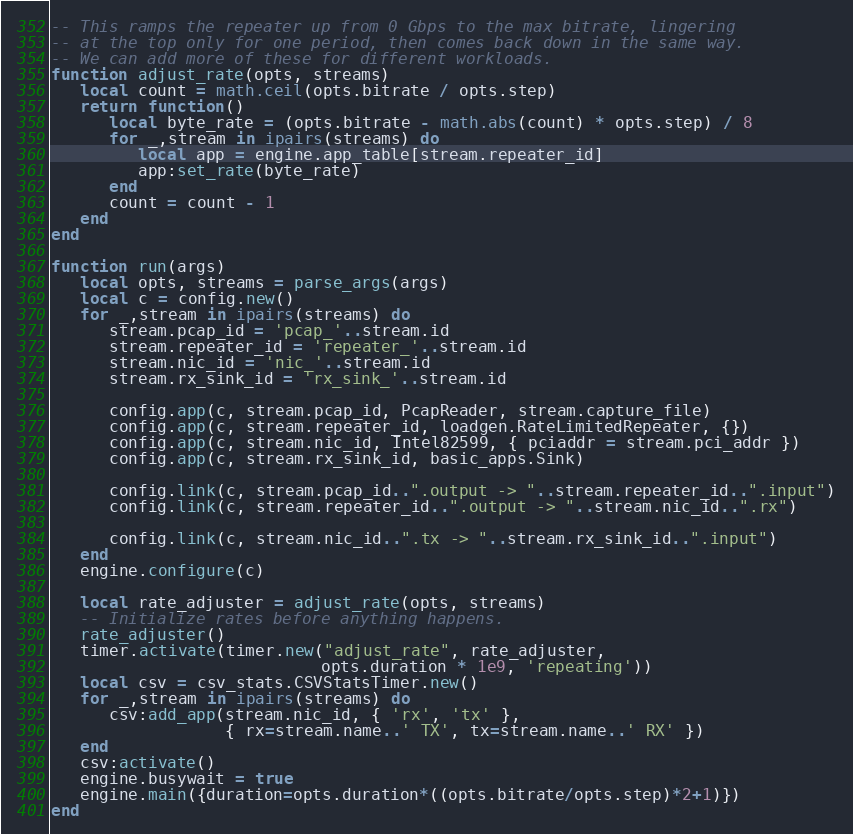<code> <loc_0><loc_0><loc_500><loc_500><_Lua_>
-- This ramps the repeater up from 0 Gbps to the max bitrate, lingering
-- at the top only for one period, then comes back down in the same way.
-- We can add more of these for different workloads.
function adjust_rate(opts, streams)
   local count = math.ceil(opts.bitrate / opts.step)
   return function()
      local byte_rate = (opts.bitrate - math.abs(count) * opts.step) / 8
      for _,stream in ipairs(streams) do
         local app = engine.app_table[stream.repeater_id]
         app:set_rate(byte_rate)
      end
      count = count - 1
   end
end

function run(args)
   local opts, streams = parse_args(args)
   local c = config.new()
   for _,stream in ipairs(streams) do
      stream.pcap_id = 'pcap_'..stream.id
      stream.repeater_id = 'repeater_'..stream.id
      stream.nic_id = 'nic_'..stream.id
      stream.rx_sink_id = 'rx_sink_'..stream.id

      config.app(c, stream.pcap_id, PcapReader, stream.capture_file)
      config.app(c, stream.repeater_id, loadgen.RateLimitedRepeater, {})
      config.app(c, stream.nic_id, Intel82599, { pciaddr = stream.pci_addr })
      config.app(c, stream.rx_sink_id, basic_apps.Sink)

      config.link(c, stream.pcap_id..".output -> "..stream.repeater_id..".input")
      config.link(c, stream.repeater_id..".output -> "..stream.nic_id..".rx")

      config.link(c, stream.nic_id..".tx -> "..stream.rx_sink_id..".input")
   end
   engine.configure(c)

   local rate_adjuster = adjust_rate(opts, streams)
   -- Initialize rates before anything happens.
   rate_adjuster()
   timer.activate(timer.new("adjust_rate", rate_adjuster,
                            opts.duration * 1e9, 'repeating'))
   local csv = csv_stats.CSVStatsTimer.new()
   for _,stream in ipairs(streams) do
      csv:add_app(stream.nic_id, { 'rx', 'tx' },
                  { rx=stream.name..' TX', tx=stream.name..' RX' })
   end
   csv:activate()
   engine.busywait = true
   engine.main({duration=opts.duration*((opts.bitrate/opts.step)*2+1)})
end
</code> 